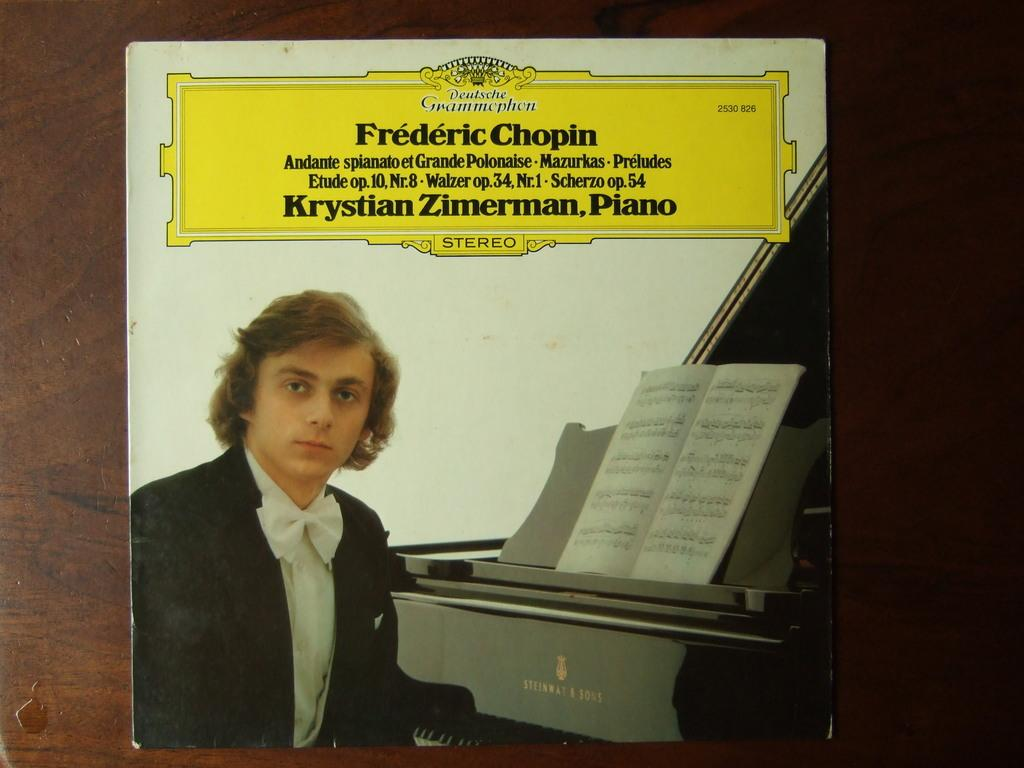<image>
Render a clear and concise summary of the photo. An album of works by Frederic Chopin sits on a table. 